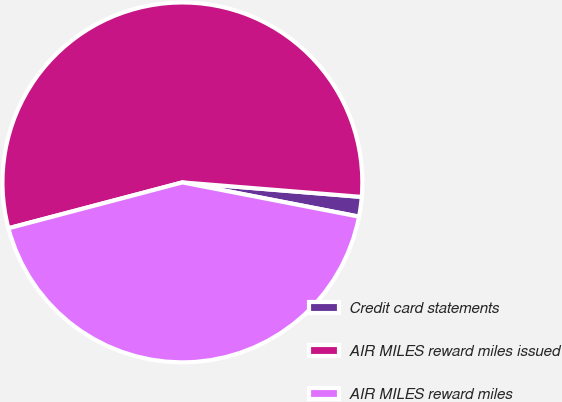Convert chart. <chart><loc_0><loc_0><loc_500><loc_500><pie_chart><fcel>Credit card statements<fcel>AIR MILES reward miles issued<fcel>AIR MILES reward miles<nl><fcel>1.76%<fcel>55.39%<fcel>42.85%<nl></chart> 